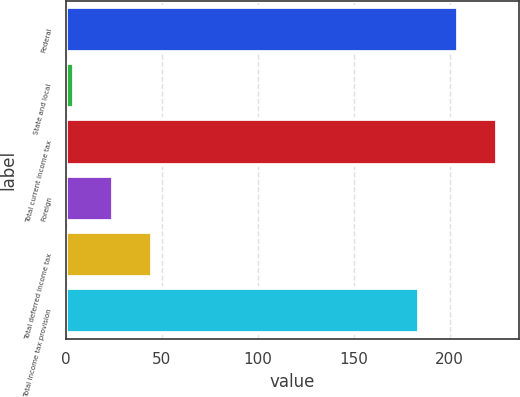<chart> <loc_0><loc_0><loc_500><loc_500><bar_chart><fcel>Federal<fcel>State and local<fcel>Total current income tax<fcel>Foreign<fcel>Total deferred income tax<fcel>Total income tax provision<nl><fcel>204.4<fcel>4<fcel>224.8<fcel>24.4<fcel>44.8<fcel>184<nl></chart> 